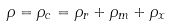Convert formula to latex. <formula><loc_0><loc_0><loc_500><loc_500>\rho = \rho _ { c } = \rho _ { r } + \rho _ { m } + \rho _ { x }</formula> 